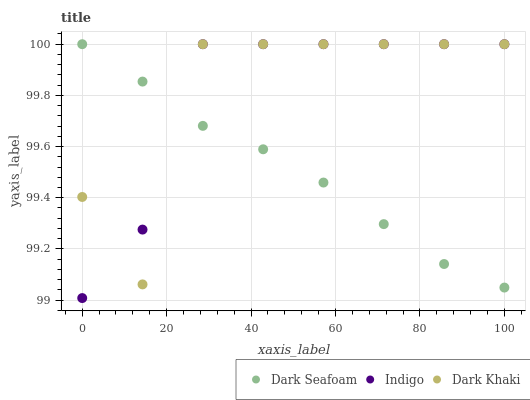Does Dark Seafoam have the minimum area under the curve?
Answer yes or no. Yes. Does Indigo have the maximum area under the curve?
Answer yes or no. Yes. Does Indigo have the minimum area under the curve?
Answer yes or no. No. Does Dark Seafoam have the maximum area under the curve?
Answer yes or no. No. Is Dark Seafoam the smoothest?
Answer yes or no. Yes. Is Dark Khaki the roughest?
Answer yes or no. Yes. Is Indigo the smoothest?
Answer yes or no. No. Is Indigo the roughest?
Answer yes or no. No. Does Indigo have the lowest value?
Answer yes or no. Yes. Does Dark Seafoam have the lowest value?
Answer yes or no. No. Does Indigo have the highest value?
Answer yes or no. Yes. Does Dark Khaki intersect Indigo?
Answer yes or no. Yes. Is Dark Khaki less than Indigo?
Answer yes or no. No. Is Dark Khaki greater than Indigo?
Answer yes or no. No. 